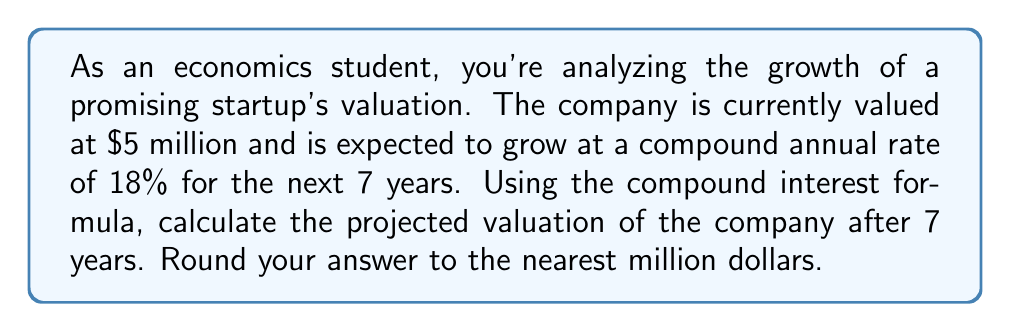Teach me how to tackle this problem. To solve this problem, we'll use the compound interest formula:

$$A = P(1 + r)^t$$

Where:
$A$ = Final amount
$P$ = Principal (initial investment)
$r$ = Annual interest rate (in decimal form)
$t$ = Time in years

Given:
$P = \$5,000,000$ (initial valuation)
$r = 18\% = 0.18$
$t = 7$ years

Let's plug these values into the formula:

$$A = 5,000,000(1 + 0.18)^7$$

Now, let's calculate step-by-step:

1) First, calculate $(1 + 0.18)^7$:
   $$(1.18)^7 \approx 3.2052$$

2) Multiply this by the initial value:
   $$5,000,000 \times 3.2052 = 16,026,000$$

3) Round to the nearest million:
   $$16,026,000 \approx 16,000,000$$

Therefore, the projected valuation of the company after 7 years is approximately $16 million.
Answer: $16 million 